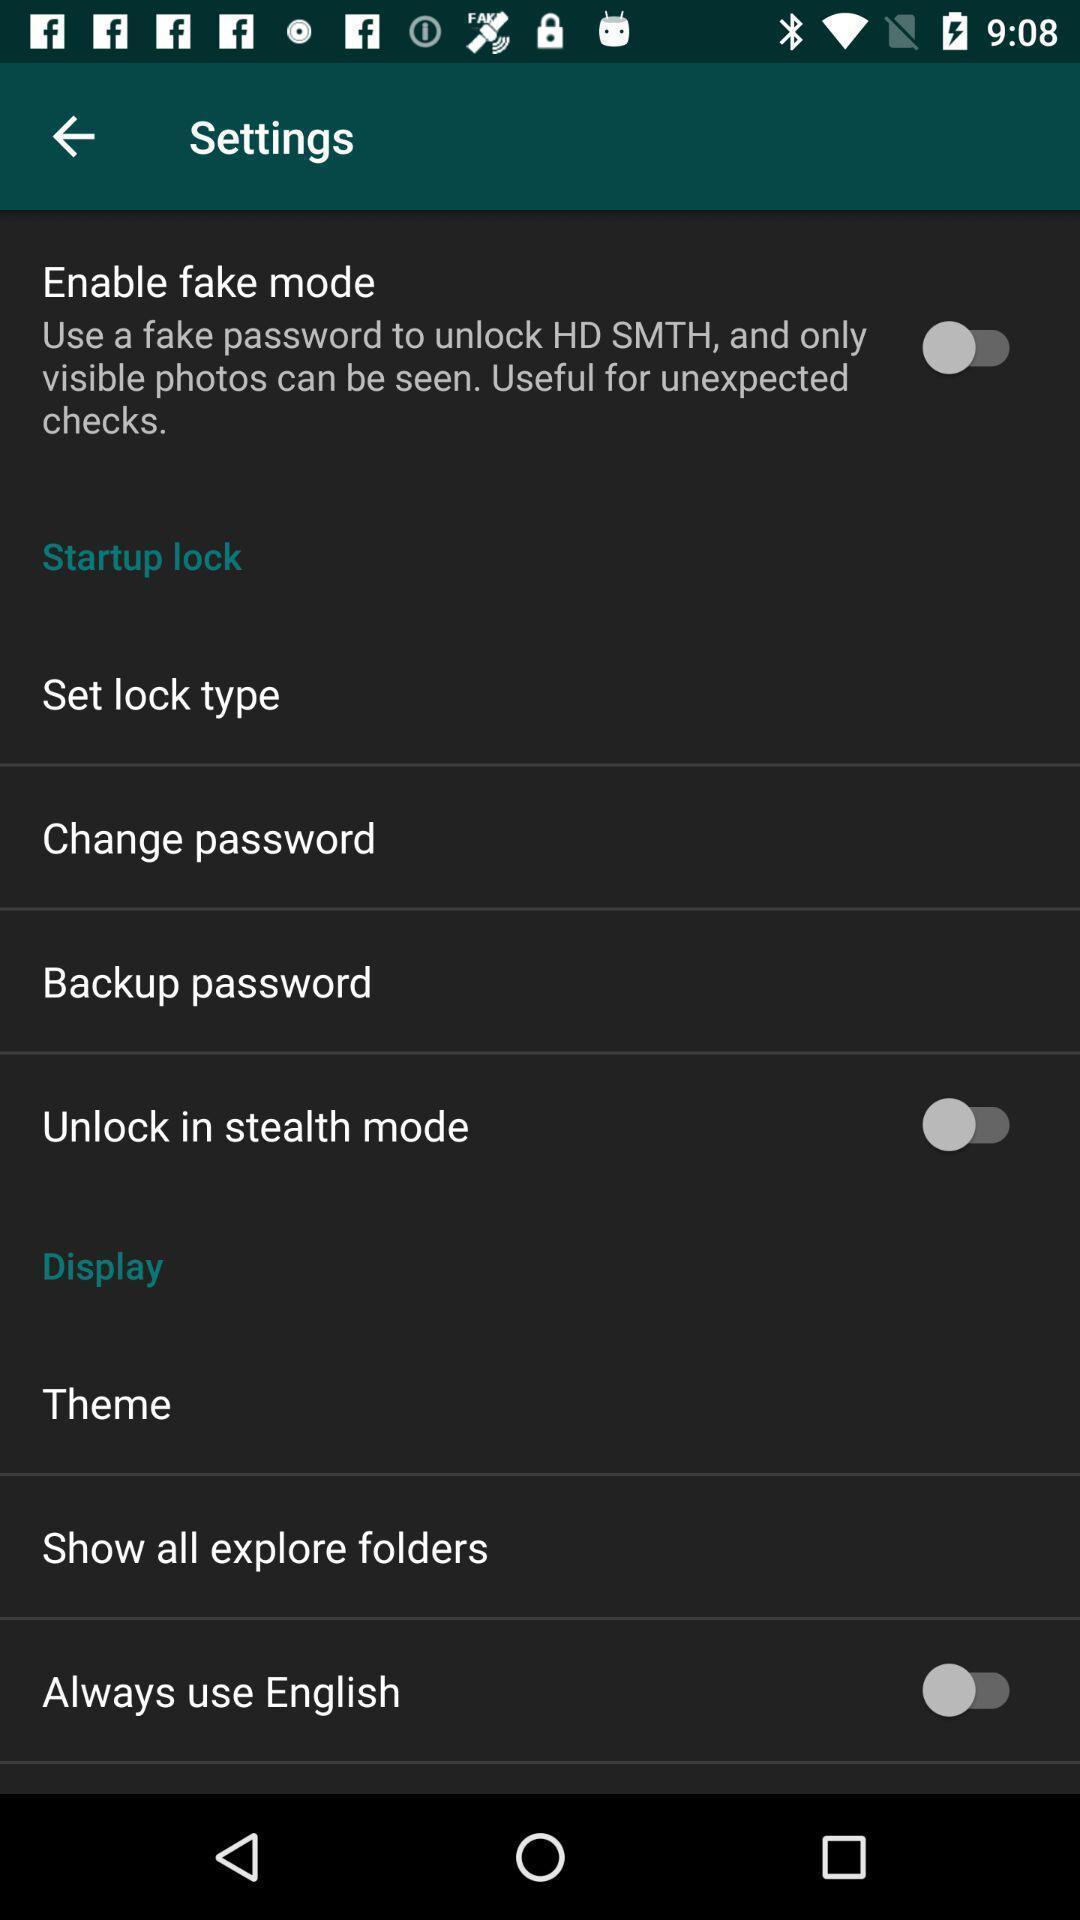Tell me what you see in this picture. Settings page with various options. 